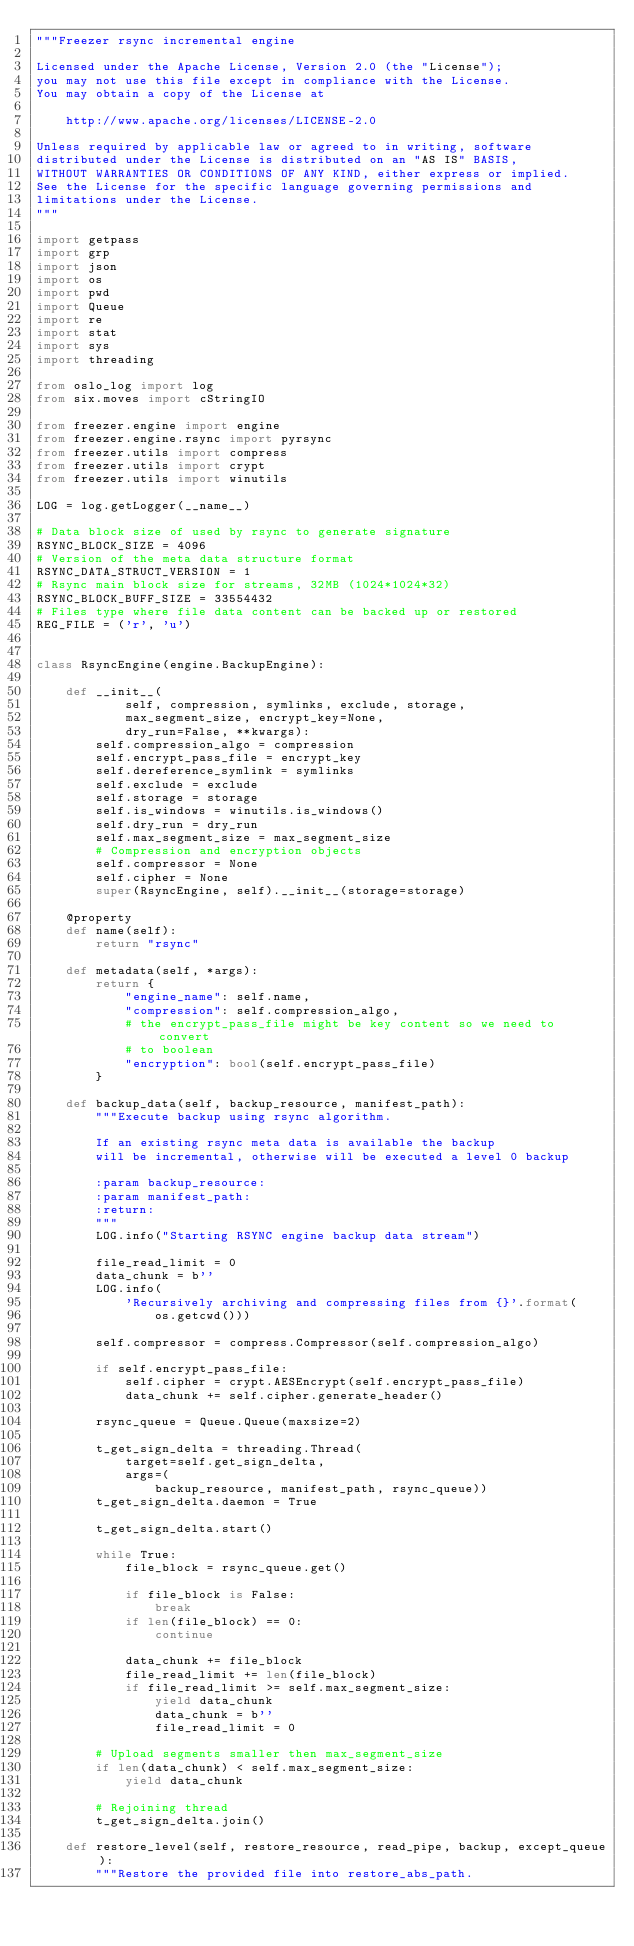Convert code to text. <code><loc_0><loc_0><loc_500><loc_500><_Python_>"""Freezer rsync incremental engine

Licensed under the Apache License, Version 2.0 (the "License");
you may not use this file except in compliance with the License.
You may obtain a copy of the License at

    http://www.apache.org/licenses/LICENSE-2.0

Unless required by applicable law or agreed to in writing, software
distributed under the License is distributed on an "AS IS" BASIS,
WITHOUT WARRANTIES OR CONDITIONS OF ANY KIND, either express or implied.
See the License for the specific language governing permissions and
limitations under the License.
"""

import getpass
import grp
import json
import os
import pwd
import Queue
import re
import stat
import sys
import threading

from oslo_log import log
from six.moves import cStringIO

from freezer.engine import engine
from freezer.engine.rsync import pyrsync
from freezer.utils import compress
from freezer.utils import crypt
from freezer.utils import winutils

LOG = log.getLogger(__name__)

# Data block size of used by rsync to generate signature
RSYNC_BLOCK_SIZE = 4096
# Version of the meta data structure format
RSYNC_DATA_STRUCT_VERSION = 1
# Rsync main block size for streams, 32MB (1024*1024*32)
RSYNC_BLOCK_BUFF_SIZE = 33554432
# Files type where file data content can be backed up or restored
REG_FILE = ('r', 'u')


class RsyncEngine(engine.BackupEngine):

    def __init__(
            self, compression, symlinks, exclude, storage,
            max_segment_size, encrypt_key=None,
            dry_run=False, **kwargs):
        self.compression_algo = compression
        self.encrypt_pass_file = encrypt_key
        self.dereference_symlink = symlinks
        self.exclude = exclude
        self.storage = storage
        self.is_windows = winutils.is_windows()
        self.dry_run = dry_run
        self.max_segment_size = max_segment_size
        # Compression and encryption objects
        self.compressor = None
        self.cipher = None
        super(RsyncEngine, self).__init__(storage=storage)

    @property
    def name(self):
        return "rsync"

    def metadata(self, *args):
        return {
            "engine_name": self.name,
            "compression": self.compression_algo,
            # the encrypt_pass_file might be key content so we need to convert
            # to boolean
            "encryption": bool(self.encrypt_pass_file)
        }

    def backup_data(self, backup_resource, manifest_path):
        """Execute backup using rsync algorithm.

        If an existing rsync meta data is available the backup
        will be incremental, otherwise will be executed a level 0 backup

        :param backup_resource:
        :param manifest_path:
        :return:
        """
        LOG.info("Starting RSYNC engine backup data stream")

        file_read_limit = 0
        data_chunk = b''
        LOG.info(
            'Recursively archiving and compressing files from {}'.format(
                os.getcwd()))

        self.compressor = compress.Compressor(self.compression_algo)

        if self.encrypt_pass_file:
            self.cipher = crypt.AESEncrypt(self.encrypt_pass_file)
            data_chunk += self.cipher.generate_header()

        rsync_queue = Queue.Queue(maxsize=2)

        t_get_sign_delta = threading.Thread(
            target=self.get_sign_delta,
            args=(
                backup_resource, manifest_path, rsync_queue))
        t_get_sign_delta.daemon = True

        t_get_sign_delta.start()

        while True:
            file_block = rsync_queue.get()

            if file_block is False:
                break
            if len(file_block) == 0:
                continue

            data_chunk += file_block
            file_read_limit += len(file_block)
            if file_read_limit >= self.max_segment_size:
                yield data_chunk
                data_chunk = b''
                file_read_limit = 0

        # Upload segments smaller then max_segment_size
        if len(data_chunk) < self.max_segment_size:
            yield data_chunk

        # Rejoining thread
        t_get_sign_delta.join()

    def restore_level(self, restore_resource, read_pipe, backup, except_queue):
        """Restore the provided file into restore_abs_path.
</code> 